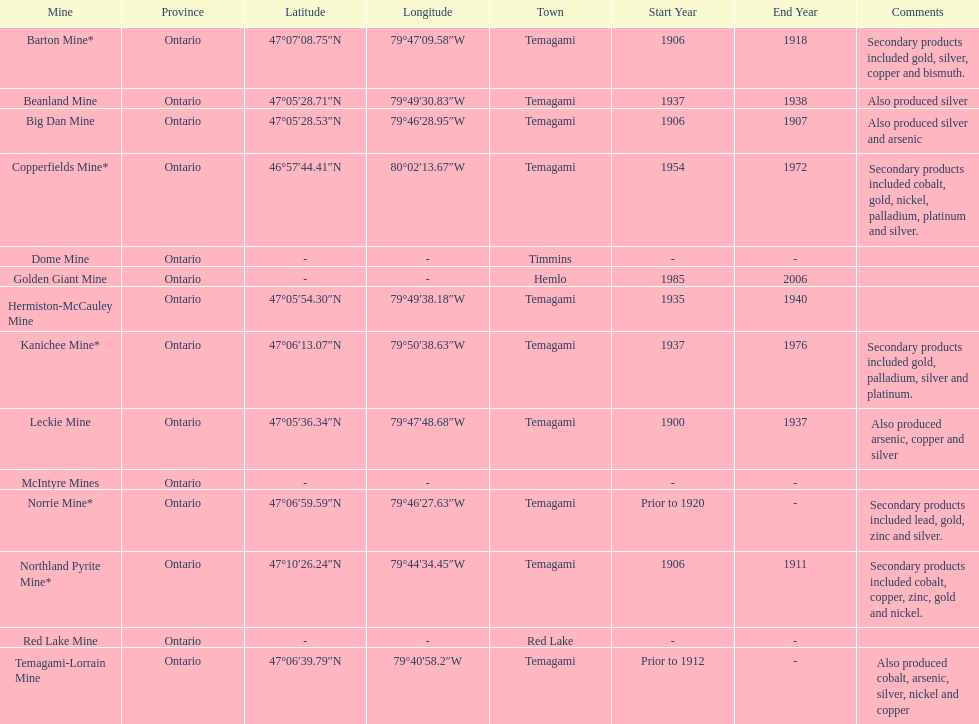Which mine was open longer, golden giant or beanland mine? Golden Giant Mine. 